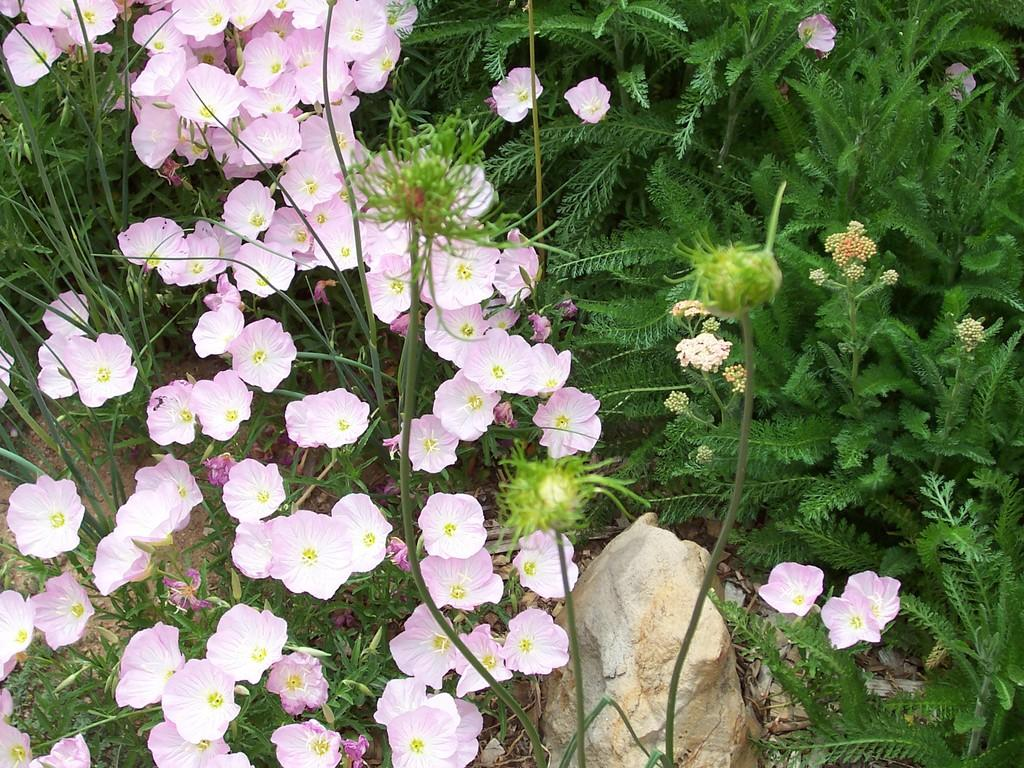What types of vegetation can be seen in the image? There are plants, flowers, and buds in the image. What is located at the bottom of the image? There is a rock and dry leaves at the bottom of the image. What type of berry can be seen growing on the rock in the image? There are no berries present in the image; it features plants, flowers, buds, a rock, and dry leaves. 